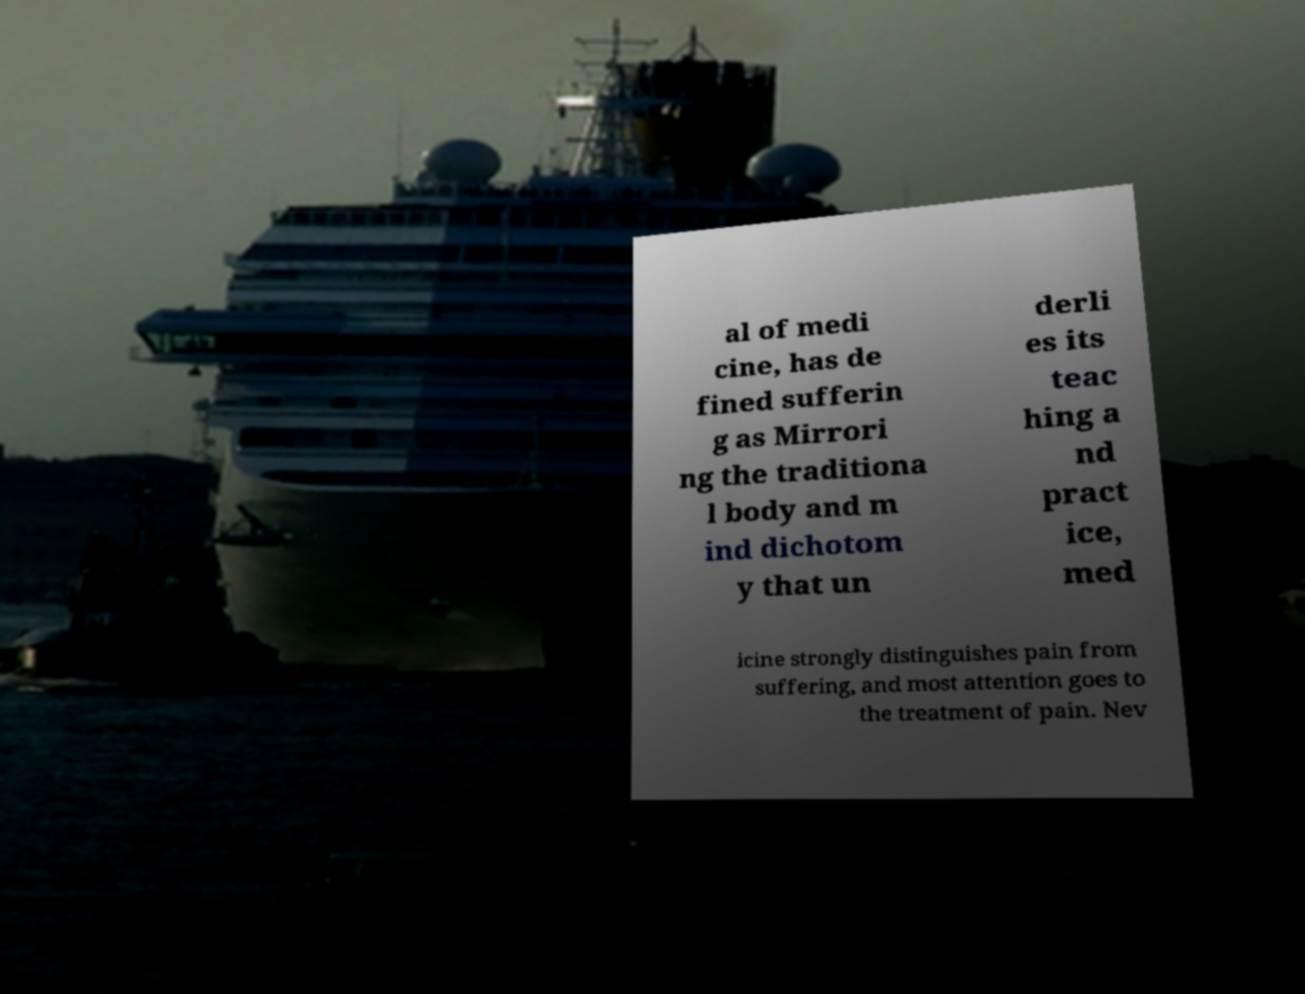Please identify and transcribe the text found in this image. al of medi cine, has de fined sufferin g as Mirrori ng the traditiona l body and m ind dichotom y that un derli es its teac hing a nd pract ice, med icine strongly distinguishes pain from suffering, and most attention goes to the treatment of pain. Nev 